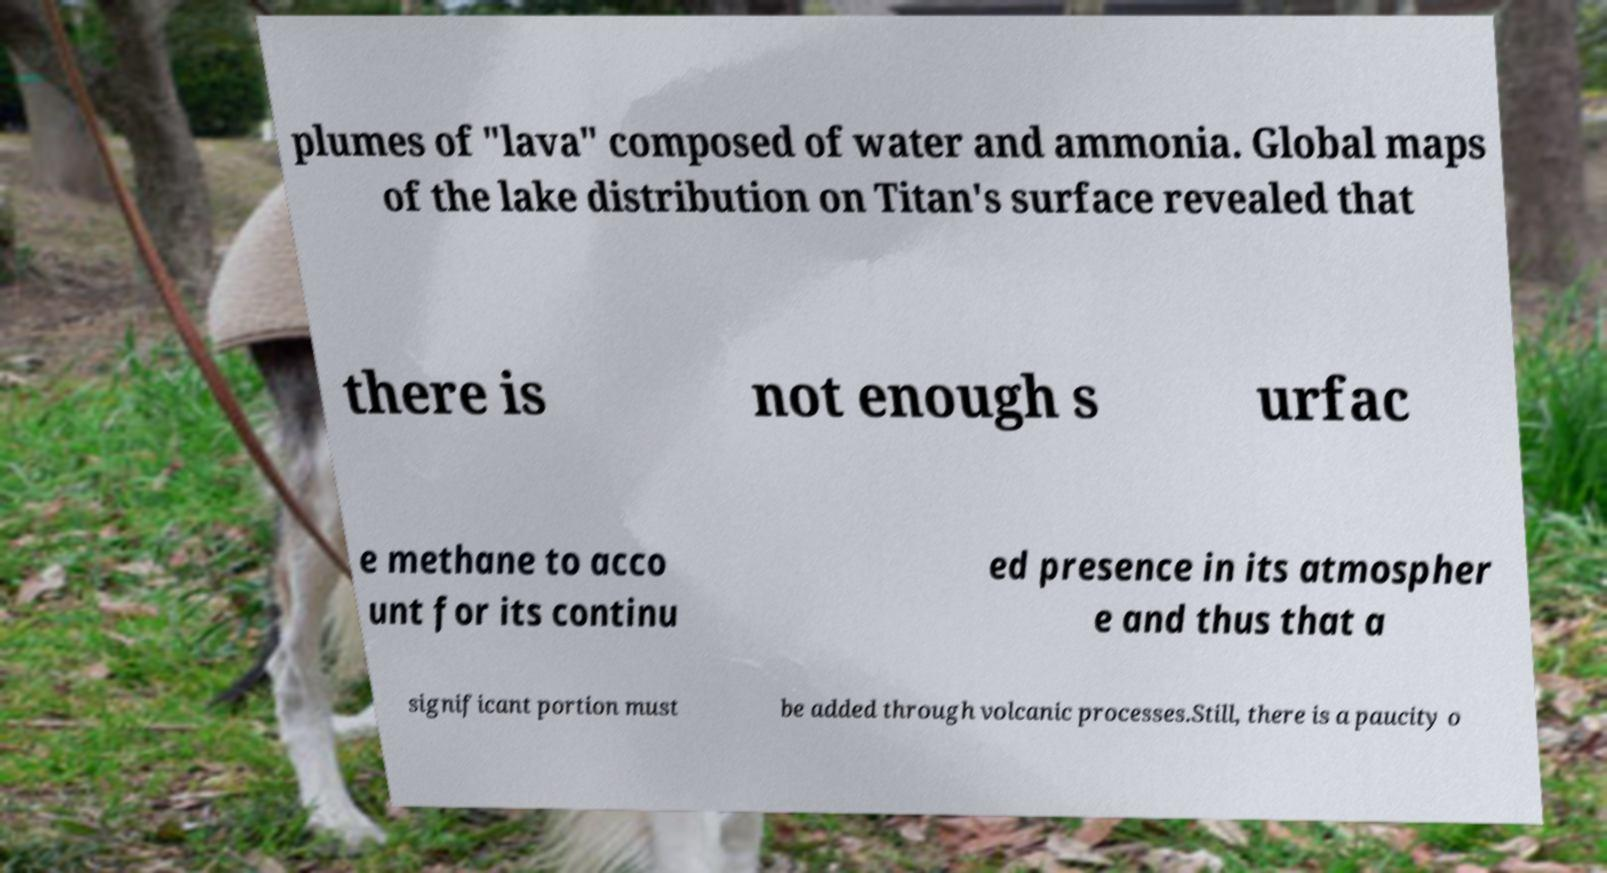Can you read and provide the text displayed in the image?This photo seems to have some interesting text. Can you extract and type it out for me? plumes of "lava" composed of water and ammonia. Global maps of the lake distribution on Titan's surface revealed that there is not enough s urfac e methane to acco unt for its continu ed presence in its atmospher e and thus that a significant portion must be added through volcanic processes.Still, there is a paucity o 